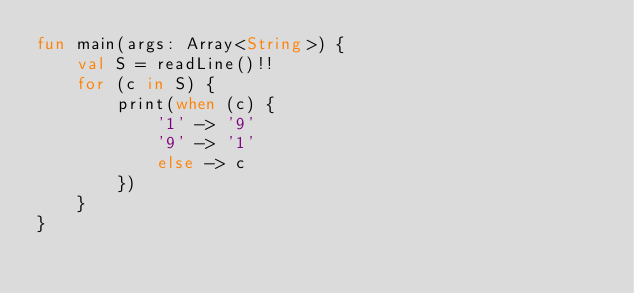Convert code to text. <code><loc_0><loc_0><loc_500><loc_500><_Kotlin_>fun main(args: Array<String>) {
    val S = readLine()!!
    for (c in S) {
        print(when (c) {
            '1' -> '9'
            '9' -> '1'
            else -> c
        })
    }
}</code> 